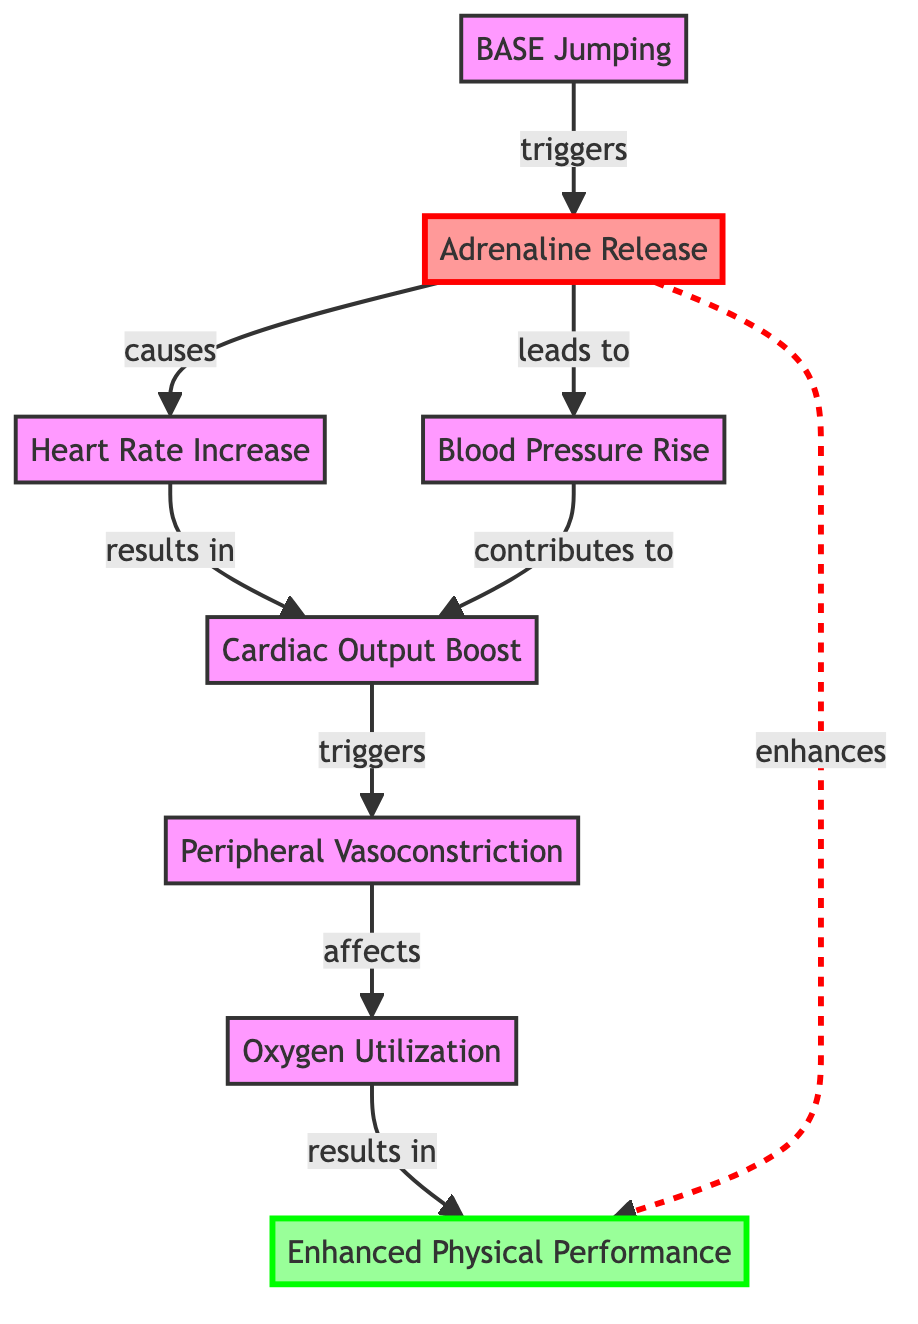What triggers the adrenaline release in this diagram? The diagram shows that BASE jumping directly triggers the adrenaline release, as indicated by the arrow pointing from "BASE Jumping" to "Adrenaline Release."
Answer: BASE Jumping How many direct effects does adrenaline have in this diagram? The diagram displays three direct effects of adrenaline: heart rate increase, blood pressure rise, and enhancement of physical performance (although the last has a dashed relationship, it still indicates enhancement). Counting these, the total is four.
Answer: Four What does the increase in heart rate result in? According to the diagram, the increase in heart rate results in cardiac output boost, as shown by the arrow leading from "Heart Rate Increase" to "Cardiac Output Boost."
Answer: Cardiac Output Boost Which element is influenced by peripheral vasoconstriction? The diagram indicates that oxygen utilization is the element affected by peripheral vasoconstriction, as shown by the arrow pointing from "Peripheral Vasoconstriction" to "Oxygen Utilization."
Answer: Oxygen Utilization How does adrenaline influence enhanced physical performance? The diagram illustrates two ways adrenaline enhances physical performance: it has a direct causative link and an additional enhancing relationship. The direct link leads through the chain of heart rate increase, cardiac output boost, and oxygen utilization, while the dashed arrow shows enhancement. Overall, adrenaline has both direct and indirect effects on performance.
Answer: Direct and Indirect Effects What two processes contribute to cardiac output boost? The diagram reveals that both heart rate increase and blood pressure rise contribute to the cardiac output boost, as indicated by the arrows flowing towards "Cardiac Output Boost."
Answer: Heart Rate Increase and Blood Pressure Rise What node leads to peripheral vasoconstriction? The diagram points out that cardiac output boost triggers peripheral vasoconstriction, depicted by the arrow flowing from "Cardiac Output Boost" to "Peripheral Vasoconstriction."
Answer: Cardiac Output Boost What type of relationship is shown between adrenaline and enhanced physical performance? The diagram shows a dashed line representing an enhancing relationship between adrenaline release and enhanced physical performance. This indicates that while there is a direct causal relationship, there’s also an enhancement effect that isn’t time-dependent.
Answer: Enhancing Relationship 